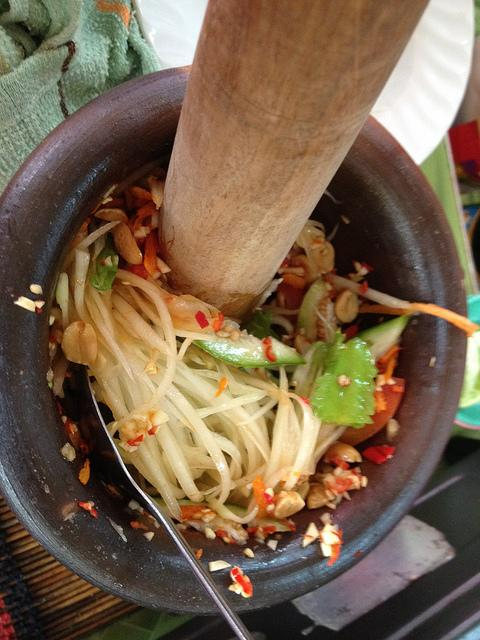What is the use of the pestle and mortar in the picture above?

Choices:
A) crash
B) none
C) smash contents
D) mix smash contents 